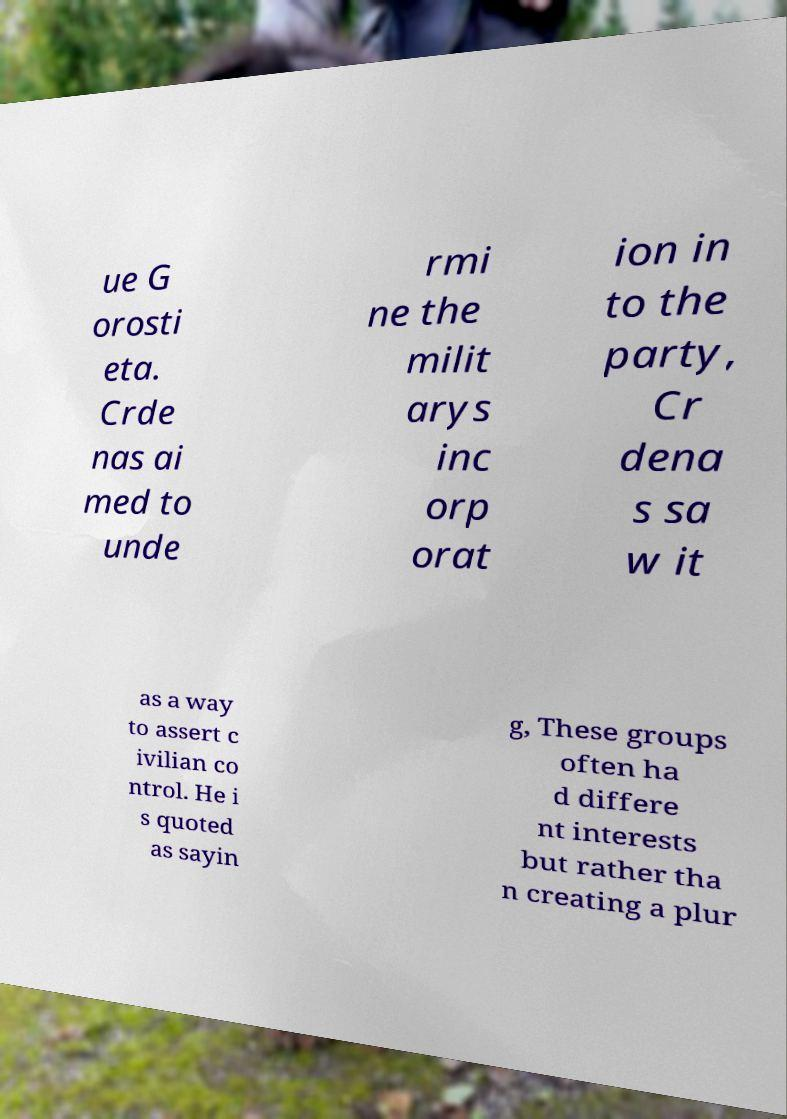Could you extract and type out the text from this image? ue G orosti eta. Crde nas ai med to unde rmi ne the milit arys inc orp orat ion in to the party, Cr dena s sa w it as a way to assert c ivilian co ntrol. He i s quoted as sayin g, These groups often ha d differe nt interests but rather tha n creating a plur 